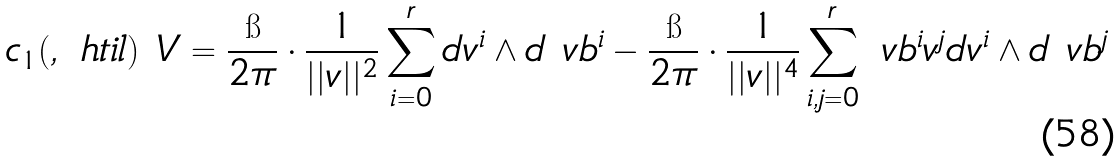<formula> <loc_0><loc_0><loc_500><loc_500>c _ { 1 } ( \L , \ h t i l ) ^ { \ } V = \frac { \i } { 2 \pi } \cdot \frac { 1 } { | | v | | ^ { 2 } } \sum _ { i = 0 } ^ { r } d v ^ { i } \wedge d \ v b ^ { i } - \frac { \i } { 2 \pi } \cdot \frac { 1 } { | | v | | ^ { 4 } } \sum _ { i , j = 0 } ^ { r } \ v b ^ { i } v ^ { j } d v ^ { i } \wedge d \ v b ^ { j }</formula> 